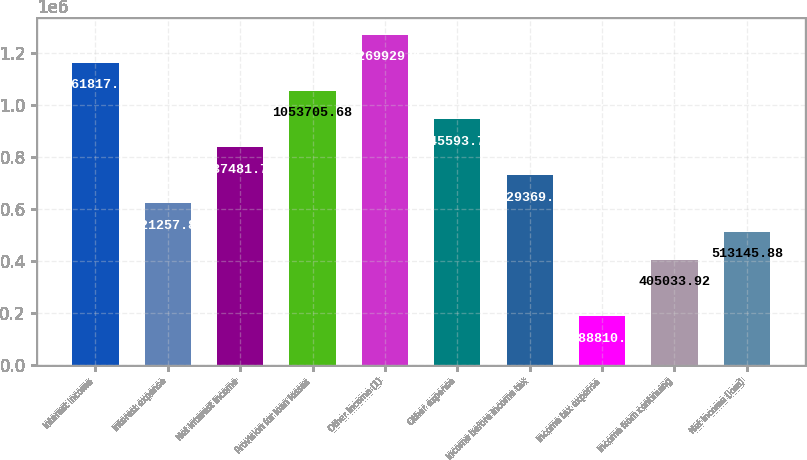Convert chart. <chart><loc_0><loc_0><loc_500><loc_500><bar_chart><fcel>Interest income<fcel>Interest expense<fcel>Net interest income<fcel>Provision for loan losses<fcel>Other income (1)<fcel>Other expense<fcel>Income before income tax<fcel>Income tax expense<fcel>Income from continuing<fcel>Net income (loss)<nl><fcel>1.16182e+06<fcel>621258<fcel>837482<fcel>1.05371e+06<fcel>1.26993e+06<fcel>945594<fcel>729370<fcel>188810<fcel>405034<fcel>513146<nl></chart> 